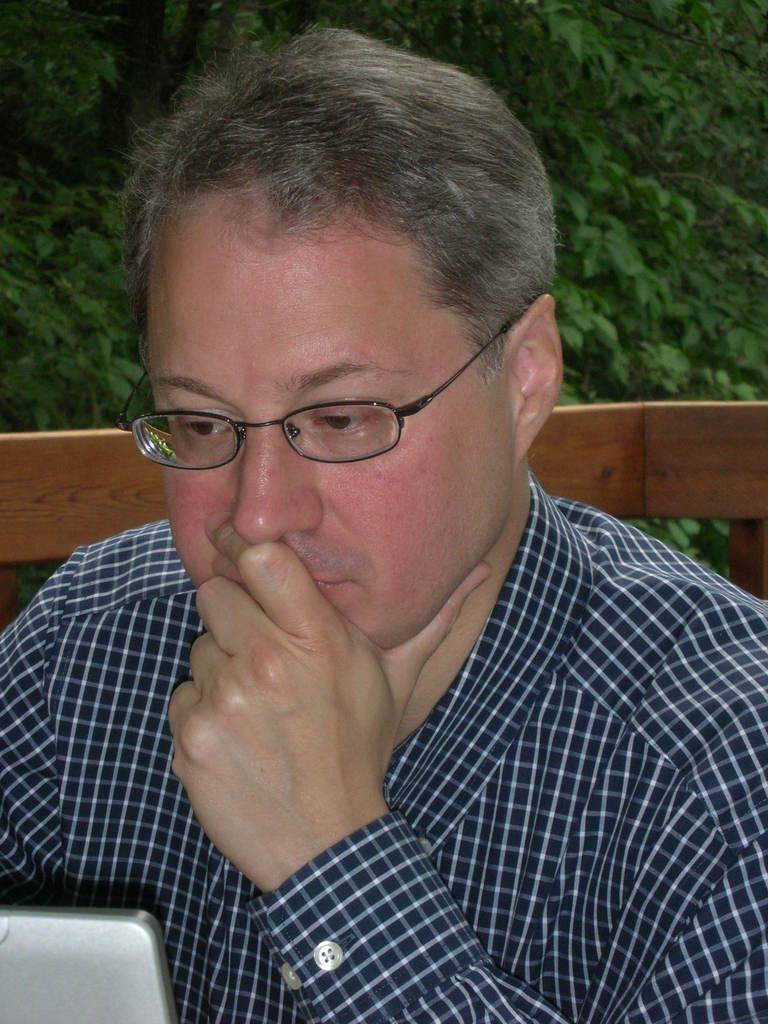Who or what is present in the image? There is a person in the image. What is the person wearing? The person is wearing a blue and green color shirt. What can be seen in the background of the image? There is a wooden object and trees in the background of the image. What is the color of the trees in the image? The trees are green in color. Can you see a giraffe in the image? No, there is no giraffe present in the image. What type of chalk is being used by the person in the image? There is no chalk visible in the image, and the person's activity is not described. 